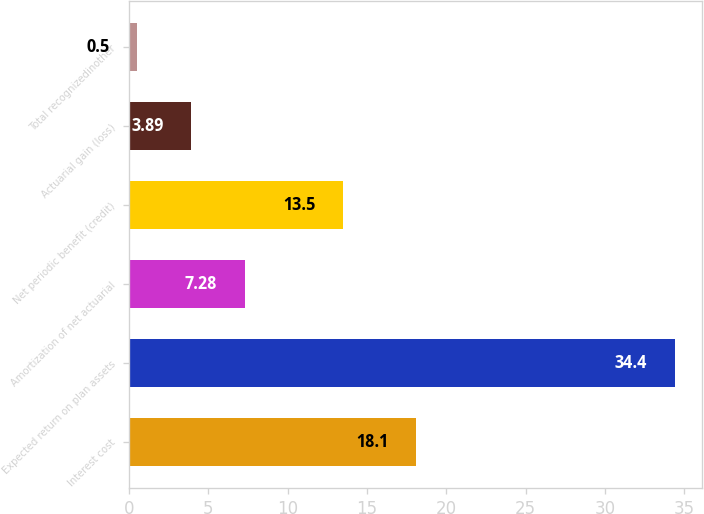Convert chart. <chart><loc_0><loc_0><loc_500><loc_500><bar_chart><fcel>Interest cost<fcel>Expected return on plan assets<fcel>Amortization of net actuarial<fcel>Net periodic benefit (credit)<fcel>Actuarial gain (loss)<fcel>Total recognizedinother<nl><fcel>18.1<fcel>34.4<fcel>7.28<fcel>13.5<fcel>3.89<fcel>0.5<nl></chart> 